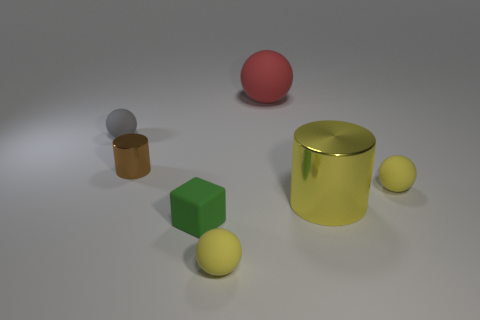Subtract all small matte spheres. How many spheres are left? 1 Subtract all yellow cylinders. How many yellow balls are left? 2 Subtract all gray balls. How many balls are left? 3 Subtract 2 balls. How many balls are left? 2 Add 1 cyan metal cylinders. How many objects exist? 8 Subtract all blue spheres. Subtract all yellow cylinders. How many spheres are left? 4 Subtract all cylinders. How many objects are left? 5 Add 4 gray rubber objects. How many gray rubber objects are left? 5 Add 4 gray objects. How many gray objects exist? 5 Subtract 1 gray balls. How many objects are left? 6 